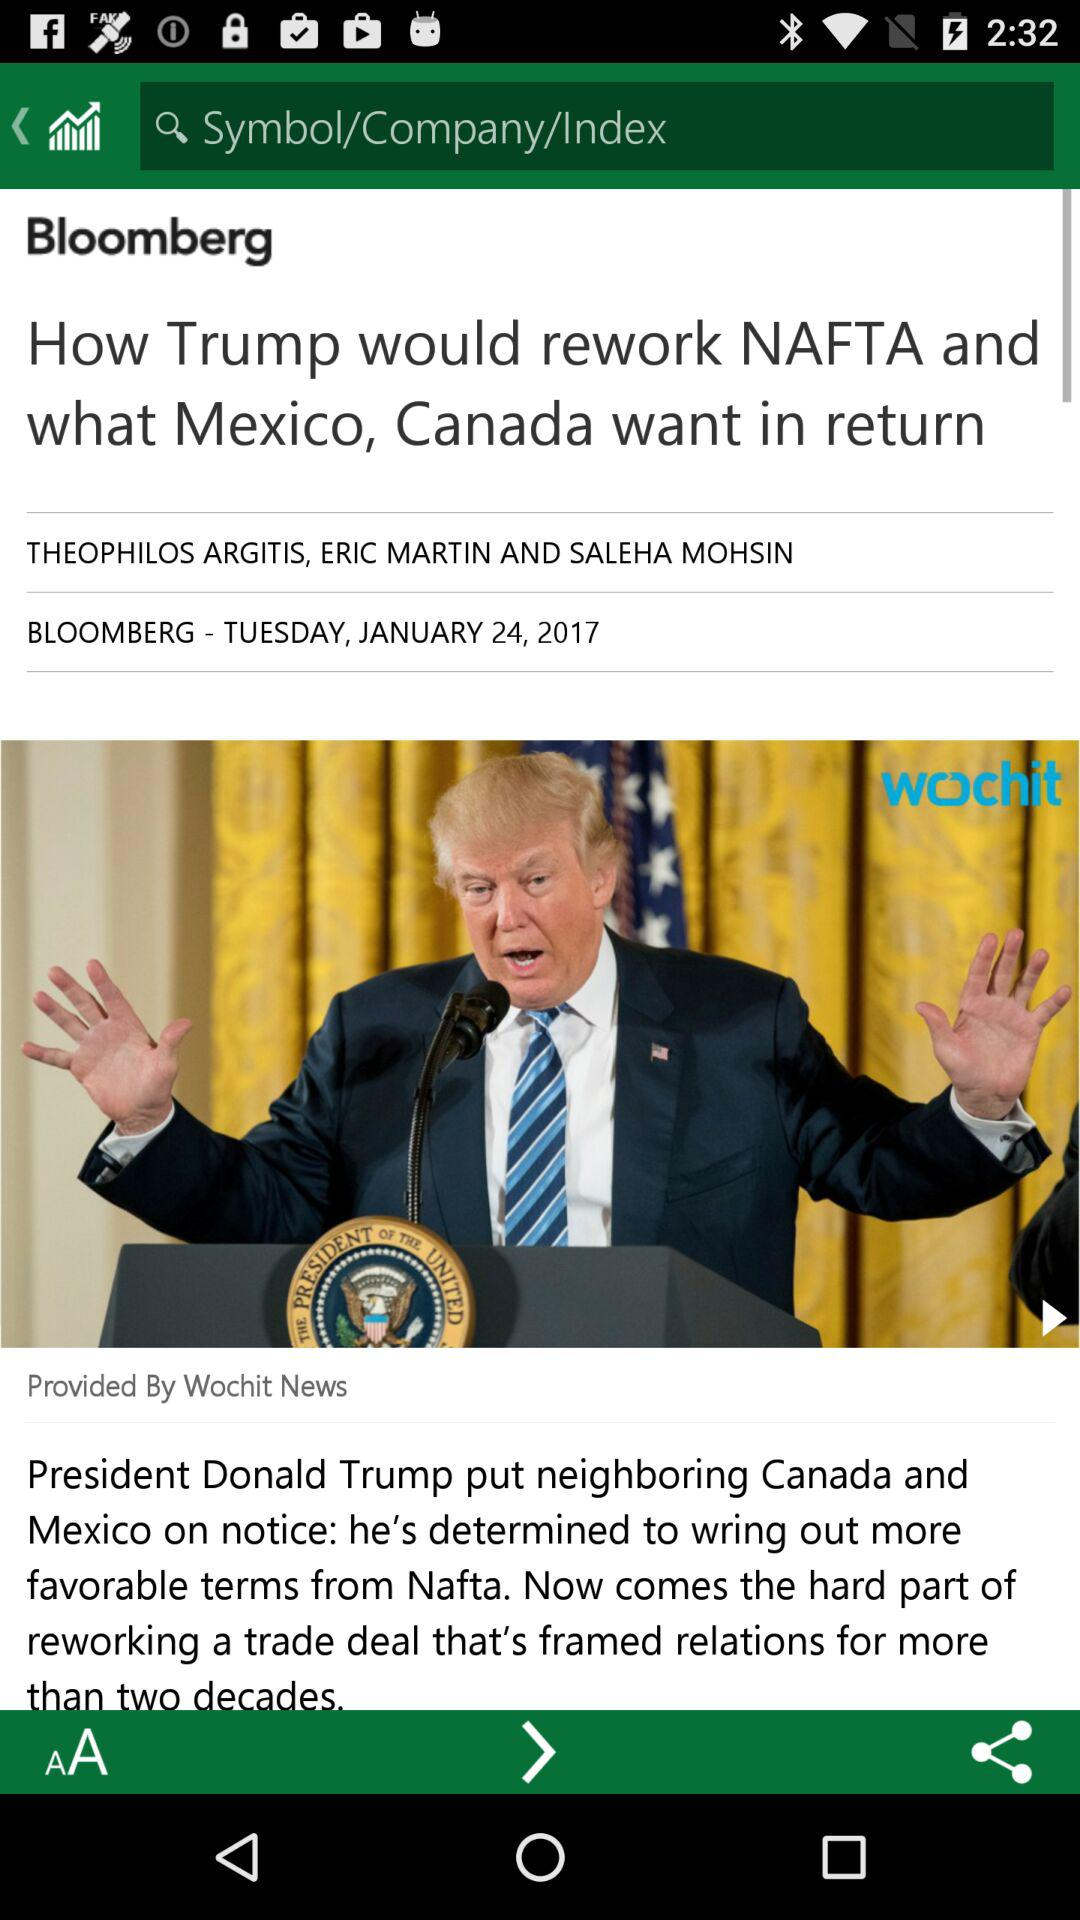Who is the provider of this article? This article is provided by Wochit News. 